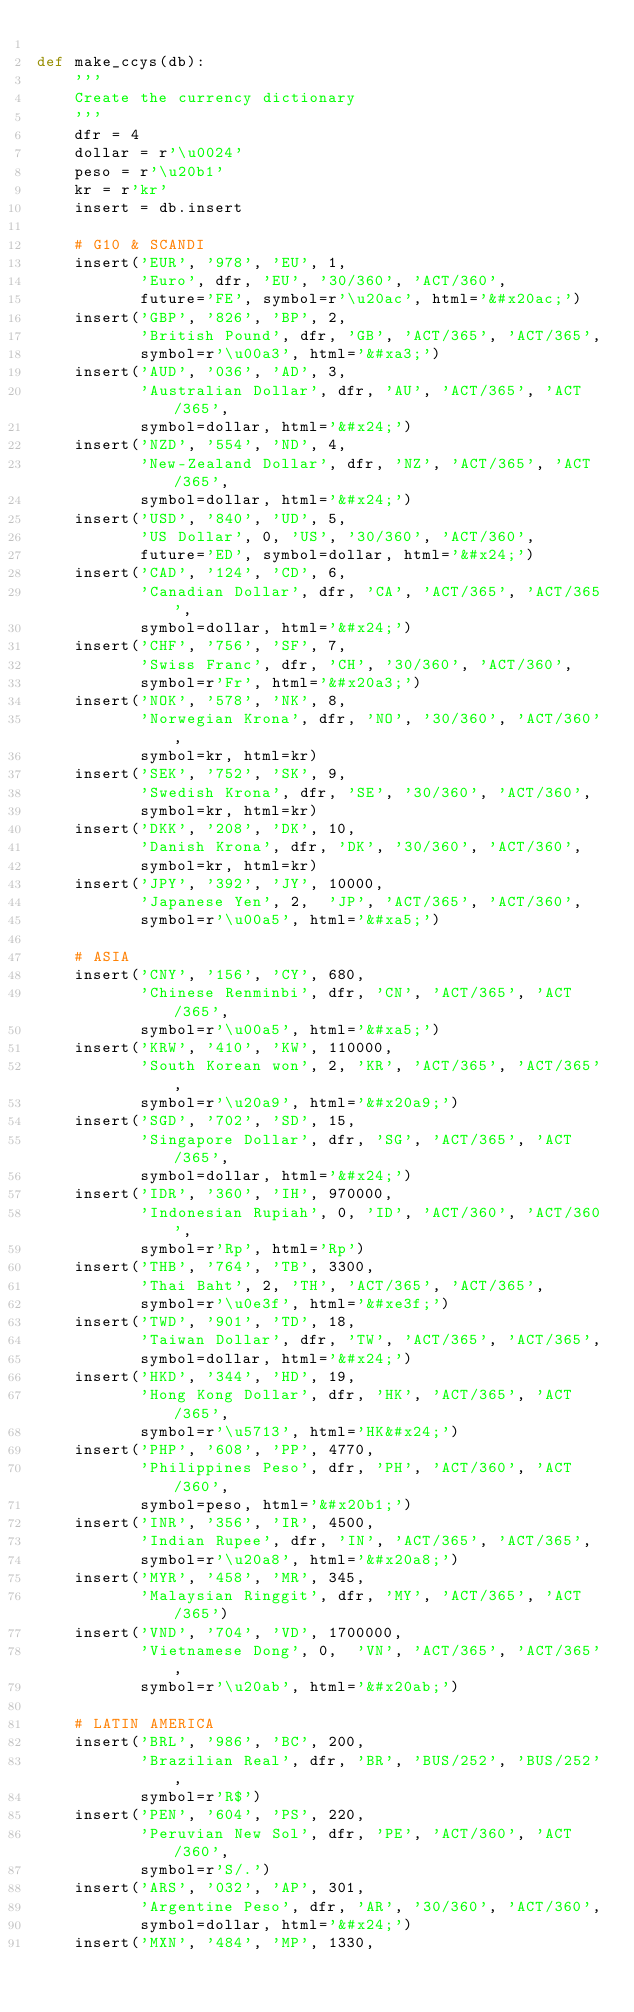<code> <loc_0><loc_0><loc_500><loc_500><_Python_>
def make_ccys(db):
    '''
    Create the currency dictionary
    '''
    dfr = 4
    dollar = r'\u0024'
    peso = r'\u20b1'
    kr = r'kr'
    insert = db.insert

    # G10 & SCANDI
    insert('EUR', '978', 'EU', 1,
           'Euro', dfr, 'EU', '30/360', 'ACT/360',
           future='FE', symbol=r'\u20ac', html='&#x20ac;')
    insert('GBP', '826', 'BP', 2,
           'British Pound', dfr, 'GB', 'ACT/365', 'ACT/365',
           symbol=r'\u00a3', html='&#xa3;')
    insert('AUD', '036', 'AD', 3,
           'Australian Dollar', dfr, 'AU', 'ACT/365', 'ACT/365',
           symbol=dollar, html='&#x24;')
    insert('NZD', '554', 'ND', 4,
           'New-Zealand Dollar', dfr, 'NZ', 'ACT/365', 'ACT/365',
           symbol=dollar, html='&#x24;')
    insert('USD', '840', 'UD', 5,
           'US Dollar', 0, 'US', '30/360', 'ACT/360',
           future='ED', symbol=dollar, html='&#x24;')
    insert('CAD', '124', 'CD', 6,
           'Canadian Dollar', dfr, 'CA', 'ACT/365', 'ACT/365',
           symbol=dollar, html='&#x24;')
    insert('CHF', '756', 'SF', 7,
           'Swiss Franc', dfr, 'CH', '30/360', 'ACT/360',
           symbol=r'Fr', html='&#x20a3;')
    insert('NOK', '578', 'NK', 8,
           'Norwegian Krona', dfr, 'NO', '30/360', 'ACT/360',
           symbol=kr, html=kr)
    insert('SEK', '752', 'SK', 9,
           'Swedish Krona', dfr, 'SE', '30/360', 'ACT/360',
           symbol=kr, html=kr)
    insert('DKK', '208', 'DK', 10,
           'Danish Krona', dfr, 'DK', '30/360', 'ACT/360',
           symbol=kr, html=kr)
    insert('JPY', '392', 'JY', 10000,
           'Japanese Yen', 2,  'JP', 'ACT/365', 'ACT/360',
           symbol=r'\u00a5', html='&#xa5;')

    # ASIA
    insert('CNY', '156', 'CY', 680,
           'Chinese Renminbi', dfr, 'CN', 'ACT/365', 'ACT/365',
           symbol=r'\u00a5', html='&#xa5;')
    insert('KRW', '410', 'KW', 110000,
           'South Korean won', 2, 'KR', 'ACT/365', 'ACT/365',
           symbol=r'\u20a9', html='&#x20a9;')
    insert('SGD', '702', 'SD', 15,
           'Singapore Dollar', dfr, 'SG', 'ACT/365', 'ACT/365',
           symbol=dollar, html='&#x24;')
    insert('IDR', '360', 'IH', 970000,
           'Indonesian Rupiah', 0, 'ID', 'ACT/360', 'ACT/360',
           symbol=r'Rp', html='Rp')
    insert('THB', '764', 'TB', 3300,
           'Thai Baht', 2, 'TH', 'ACT/365', 'ACT/365',
           symbol=r'\u0e3f', html='&#xe3f;')
    insert('TWD', '901', 'TD', 18,
           'Taiwan Dollar', dfr, 'TW', 'ACT/365', 'ACT/365',
           symbol=dollar, html='&#x24;')
    insert('HKD', '344', 'HD', 19,
           'Hong Kong Dollar', dfr, 'HK', 'ACT/365', 'ACT/365',
           symbol=r'\u5713', html='HK&#x24;')
    insert('PHP', '608', 'PP', 4770,
           'Philippines Peso', dfr, 'PH', 'ACT/360', 'ACT/360',
           symbol=peso, html='&#x20b1;')
    insert('INR', '356', 'IR', 4500,
           'Indian Rupee', dfr, 'IN', 'ACT/365', 'ACT/365',
           symbol=r'\u20a8', html='&#x20a8;')
    insert('MYR', '458', 'MR', 345,
           'Malaysian Ringgit', dfr, 'MY', 'ACT/365', 'ACT/365')
    insert('VND', '704', 'VD', 1700000,
           'Vietnamese Dong', 0,  'VN', 'ACT/365', 'ACT/365',
           symbol=r'\u20ab', html='&#x20ab;')

    # LATIN AMERICA
    insert('BRL', '986', 'BC', 200,
           'Brazilian Real', dfr, 'BR', 'BUS/252', 'BUS/252',
           symbol=r'R$')
    insert('PEN', '604', 'PS', 220,
           'Peruvian New Sol', dfr, 'PE', 'ACT/360', 'ACT/360',
           symbol=r'S/.')
    insert('ARS', '032', 'AP', 301,
           'Argentine Peso', dfr, 'AR', '30/360', 'ACT/360',
           symbol=dollar, html='&#x24;')
    insert('MXN', '484', 'MP', 1330,</code> 